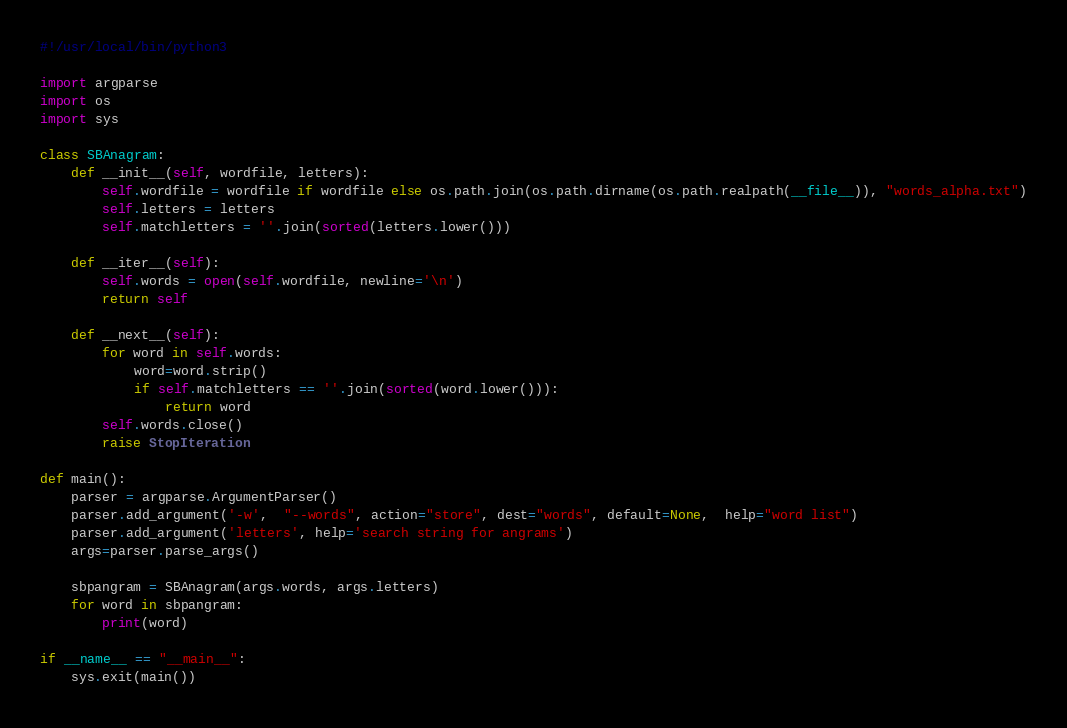<code> <loc_0><loc_0><loc_500><loc_500><_Python_>#!/usr/local/bin/python3

import argparse
import os
import sys

class SBAnagram:
    def __init__(self, wordfile, letters):
        self.wordfile = wordfile if wordfile else os.path.join(os.path.dirname(os.path.realpath(__file__)), "words_alpha.txt")
        self.letters = letters
        self.matchletters = ''.join(sorted(letters.lower()))

    def __iter__(self):
        self.words = open(self.wordfile, newline='\n')
        return self

    def __next__(self):
        for word in self.words:
            word=word.strip()
            if self.matchletters == ''.join(sorted(word.lower())):
                return word
        self.words.close()
        raise StopIteration

def main():
    parser = argparse.ArgumentParser()
    parser.add_argument('-w',  "--words", action="store", dest="words", default=None,  help="word list")
    parser.add_argument('letters', help='search string for angrams')
    args=parser.parse_args()

    sbpangram = SBAnagram(args.words, args.letters)
    for word in sbpangram:
        print(word)

if __name__ == "__main__":
    sys.exit(main())
</code> 